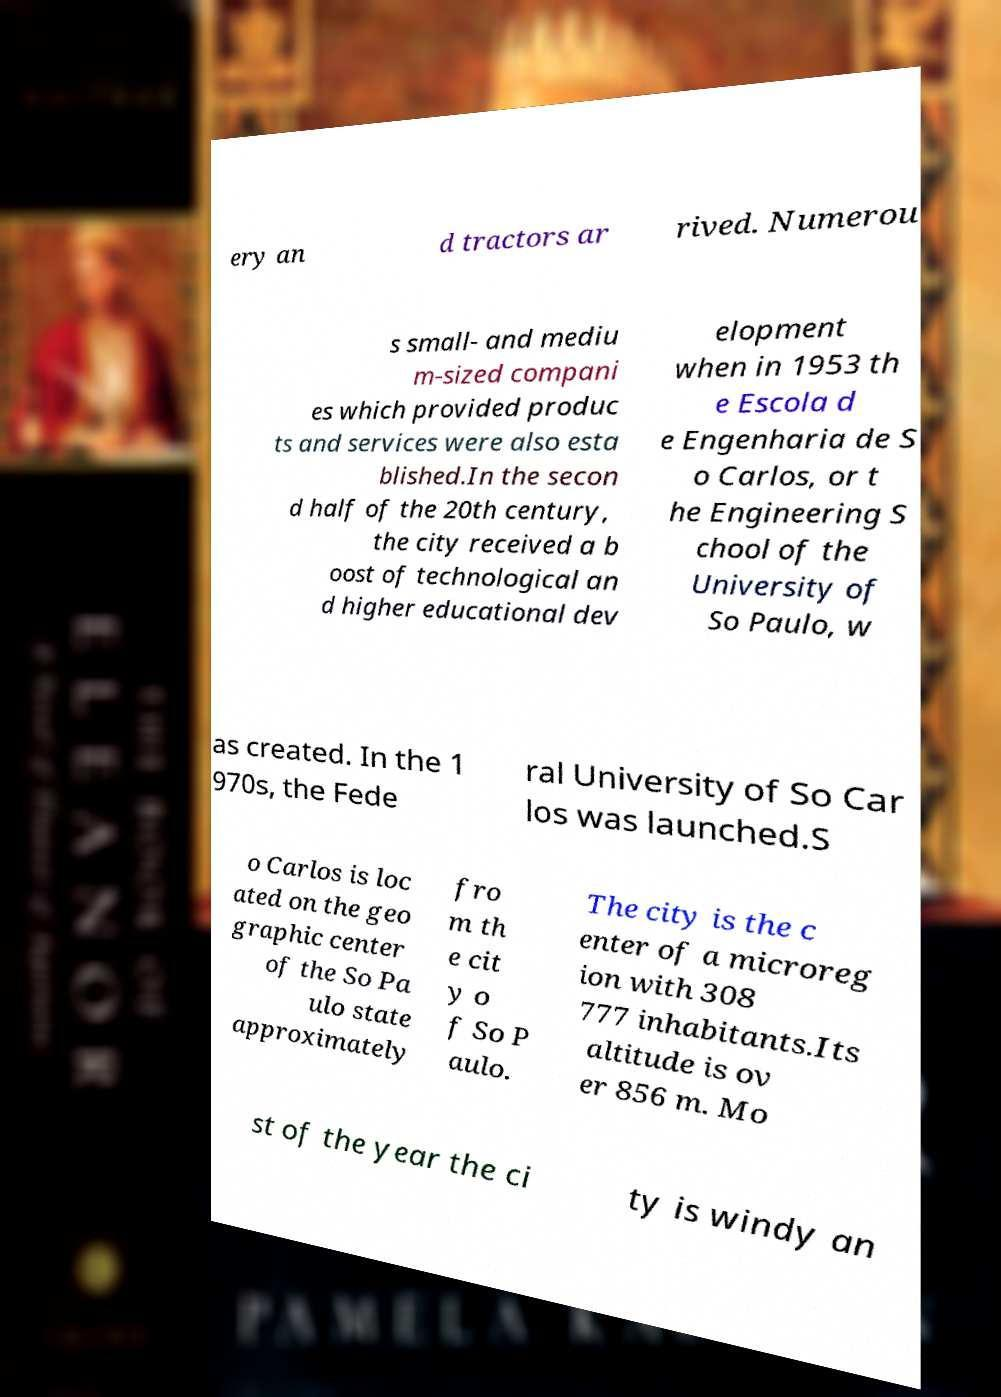What messages or text are displayed in this image? I need them in a readable, typed format. ery an d tractors ar rived. Numerou s small- and mediu m-sized compani es which provided produc ts and services were also esta blished.In the secon d half of the 20th century, the city received a b oost of technological an d higher educational dev elopment when in 1953 th e Escola d e Engenharia de S o Carlos, or t he Engineering S chool of the University of So Paulo, w as created. In the 1 970s, the Fede ral University of So Car los was launched.S o Carlos is loc ated on the geo graphic center of the So Pa ulo state approximately fro m th e cit y o f So P aulo. The city is the c enter of a microreg ion with 308 777 inhabitants.Its altitude is ov er 856 m. Mo st of the year the ci ty is windy an 